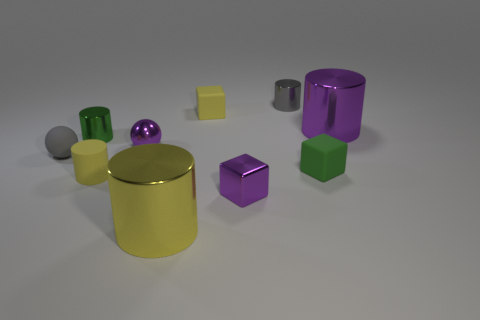There is a large cylinder that is right of the yellow rubber cube; what color is it?
Ensure brevity in your answer.  Purple. There is a metallic object on the left side of the rubber cylinder; is it the same size as the yellow thing that is behind the big purple cylinder?
Ensure brevity in your answer.  Yes. There is a small cylinder that is behind the large shiny cylinder that is on the right side of the gray metal object; what is its material?
Provide a succinct answer. Metal. How many green shiny things have the same shape as the large purple metallic object?
Your answer should be very brief. 1. Are there any matte spheres of the same color as the small matte cylinder?
Your answer should be very brief. No. What number of things are either tiny metallic objects in front of the gray ball or large metal things that are in front of the small gray matte ball?
Provide a short and direct response. 2. Are there any rubber things in front of the block that is in front of the small yellow rubber cylinder?
Make the answer very short. No. There is a green metal thing that is the same size as the yellow cube; what is its shape?
Provide a succinct answer. Cylinder. How many objects are small matte things in front of the gray rubber object or small shiny balls?
Your response must be concise. 3. How many other objects are there of the same material as the tiny yellow cube?
Ensure brevity in your answer.  3. 